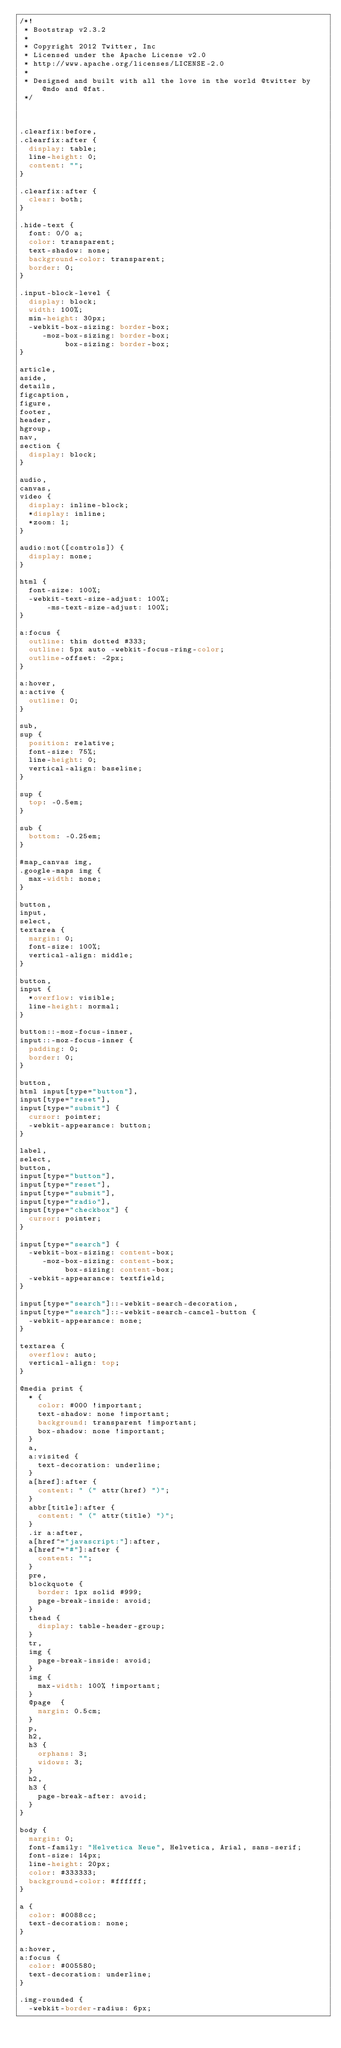<code> <loc_0><loc_0><loc_500><loc_500><_CSS_>/*!
 * Bootstrap v2.3.2
 *
 * Copyright 2012 Twitter, Inc
 * Licensed under the Apache License v2.0
 * http://www.apache.org/licenses/LICENSE-2.0
 *
 * Designed and built with all the love in the world @twitter by @mdo and @fat.
 */



.clearfix:before,
.clearfix:after {
  display: table;
  line-height: 0;
  content: "";
}

.clearfix:after {
  clear: both;
}

.hide-text {
  font: 0/0 a;
  color: transparent;
  text-shadow: none;
  background-color: transparent;
  border: 0;
}

.input-block-level {
  display: block;
  width: 100%;
  min-height: 30px;
  -webkit-box-sizing: border-box;
     -moz-box-sizing: border-box;
          box-sizing: border-box;
}

article,
aside,
details,
figcaption,
figure,
footer,
header,
hgroup,
nav,
section {
  display: block;
}

audio,
canvas,
video {
  display: inline-block;
  *display: inline;
  *zoom: 1;
}

audio:not([controls]) {
  display: none;
}

html {
  font-size: 100%;
  -webkit-text-size-adjust: 100%;
      -ms-text-size-adjust: 100%;
}

a:focus {
  outline: thin dotted #333;
  outline: 5px auto -webkit-focus-ring-color;
  outline-offset: -2px;
}

a:hover,
a:active {
  outline: 0;
}

sub,
sup {
  position: relative;
  font-size: 75%;
  line-height: 0;
  vertical-align: baseline;
}

sup {
  top: -0.5em;
}

sub {
  bottom: -0.25em;
}

#map_canvas img,
.google-maps img {
  max-width: none;
}

button,
input,
select,
textarea {
  margin: 0;
  font-size: 100%;
  vertical-align: middle;
}

button,
input {
  *overflow: visible;
  line-height: normal;
}

button::-moz-focus-inner,
input::-moz-focus-inner {
  padding: 0;
  border: 0;
}

button,
html input[type="button"],
input[type="reset"],
input[type="submit"] {
  cursor: pointer;
  -webkit-appearance: button;
}

label,
select,
button,
input[type="button"],
input[type="reset"],
input[type="submit"],
input[type="radio"],
input[type="checkbox"] {
  cursor: pointer;
}

input[type="search"] {
  -webkit-box-sizing: content-box;
     -moz-box-sizing: content-box;
          box-sizing: content-box;
  -webkit-appearance: textfield;
}

input[type="search"]::-webkit-search-decoration,
input[type="search"]::-webkit-search-cancel-button {
  -webkit-appearance: none;
}

textarea {
  overflow: auto;
  vertical-align: top;
}

@media print {
  * {
    color: #000 !important;
    text-shadow: none !important;
    background: transparent !important;
    box-shadow: none !important;
  }
  a,
  a:visited {
    text-decoration: underline;
  }
  a[href]:after {
    content: " (" attr(href) ")";
  }
  abbr[title]:after {
    content: " (" attr(title) ")";
  }
  .ir a:after,
  a[href^="javascript:"]:after,
  a[href^="#"]:after {
    content: "";
  }
  pre,
  blockquote {
    border: 1px solid #999;
    page-break-inside: avoid;
  }
  thead {
    display: table-header-group;
  }
  tr,
  img {
    page-break-inside: avoid;
  }
  img {
    max-width: 100% !important;
  }
  @page  {
    margin: 0.5cm;
  }
  p,
  h2,
  h3 {
    orphans: 3;
    widows: 3;
  }
  h2,
  h3 {
    page-break-after: avoid;
  }
}

body {
  margin: 0;
  font-family: "Helvetica Neue", Helvetica, Arial, sans-serif;
  font-size: 14px;
  line-height: 20px;
  color: #333333;
  background-color: #ffffff;
}

a {
  color: #0088cc;
  text-decoration: none;
}

a:hover,
a:focus {
  color: #005580;
  text-decoration: underline;
}

.img-rounded {
  -webkit-border-radius: 6px;</code> 